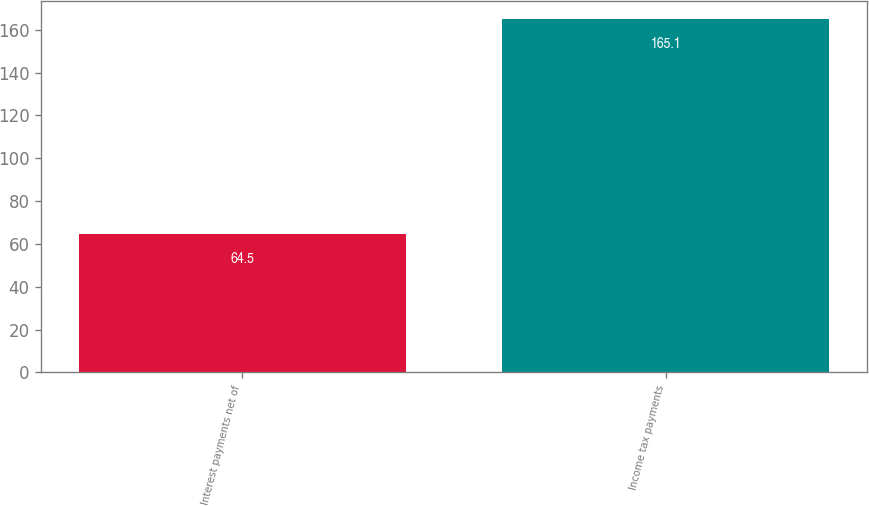Convert chart. <chart><loc_0><loc_0><loc_500><loc_500><bar_chart><fcel>Interest payments net of<fcel>Income tax payments<nl><fcel>64.5<fcel>165.1<nl></chart> 